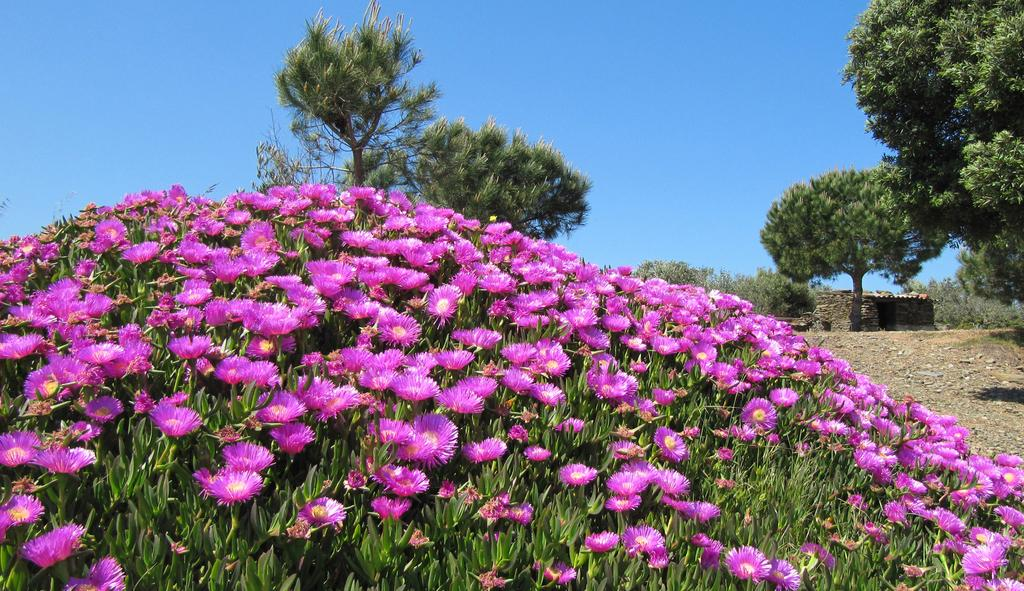What type of plants are featured in the image? There is a group of plants with flowers in the image. What color are the flowers on the plants? The flowers are violet in color. What can be seen in the background of the image? There are trees in the background of the image. What part of the natural environment is visible in the background? The sky is visible in the background of the image. What type of caption is written on the image? There is no caption present in the image. How many people are in the crowd in the image? There is no crowd present in the image; it features a group of plants with flowers. 